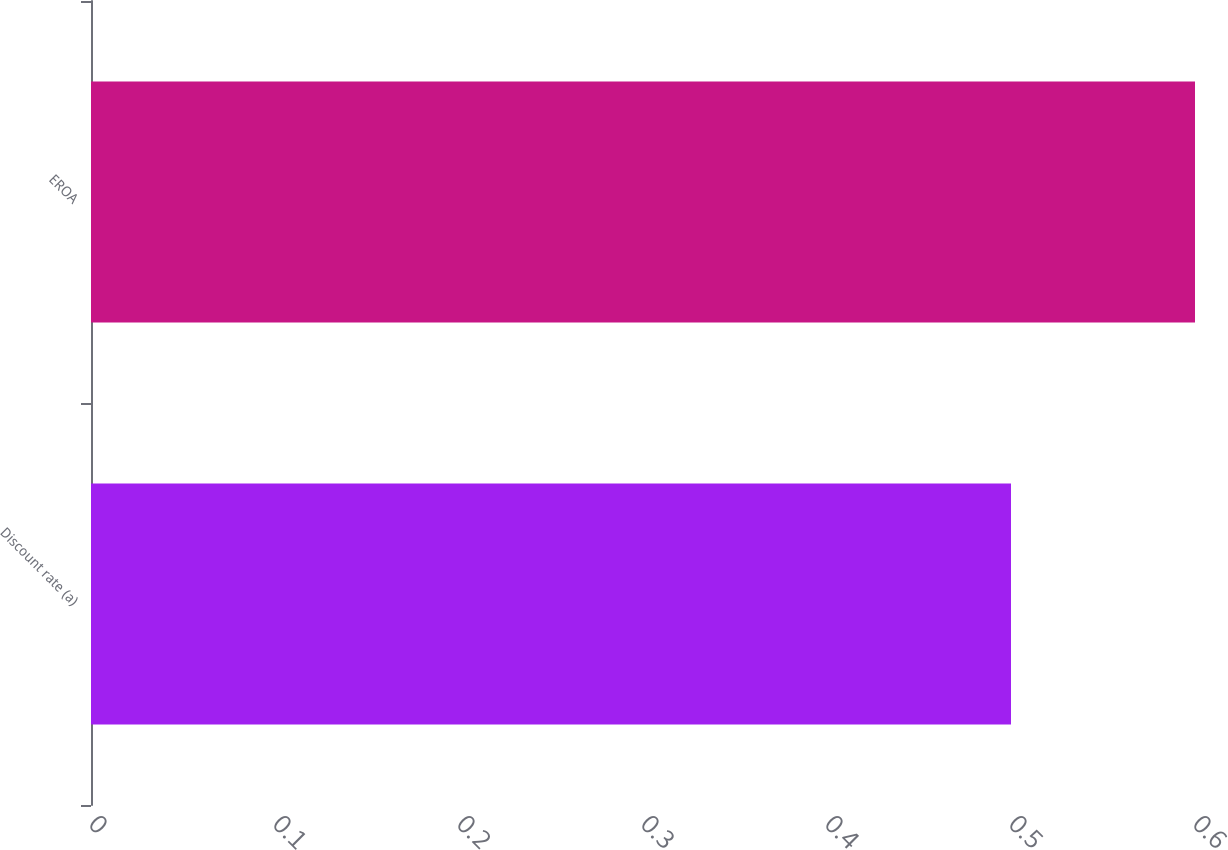Convert chart. <chart><loc_0><loc_0><loc_500><loc_500><bar_chart><fcel>Discount rate (a)<fcel>EROA<nl><fcel>0.5<fcel>0.6<nl></chart> 